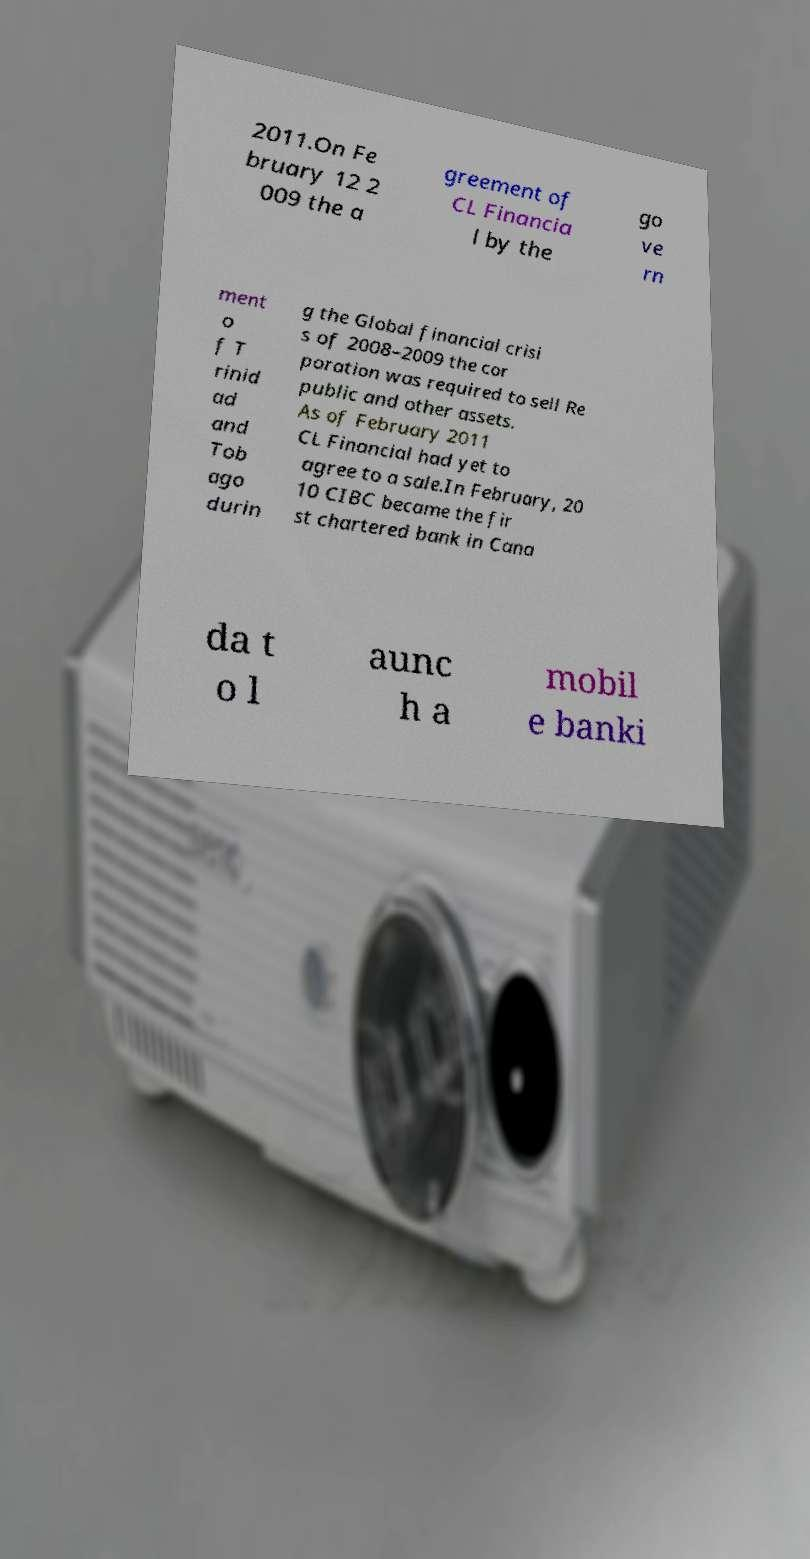Could you extract and type out the text from this image? 2011.On Fe bruary 12 2 009 the a greement of CL Financia l by the go ve rn ment o f T rinid ad and Tob ago durin g the Global financial crisi s of 2008–2009 the cor poration was required to sell Re public and other assets. As of February 2011 CL Financial had yet to agree to a sale.In February, 20 10 CIBC became the fir st chartered bank in Cana da t o l aunc h a mobil e banki 